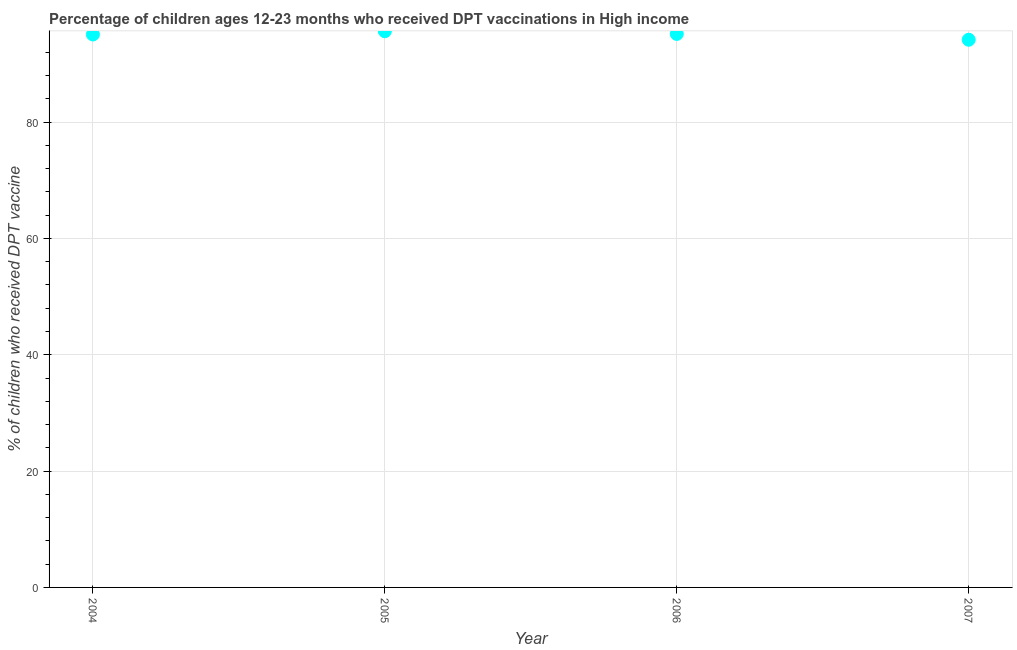What is the percentage of children who received dpt vaccine in 2006?
Your answer should be compact. 95.16. Across all years, what is the maximum percentage of children who received dpt vaccine?
Your response must be concise. 95.61. Across all years, what is the minimum percentage of children who received dpt vaccine?
Your answer should be very brief. 94.16. In which year was the percentage of children who received dpt vaccine minimum?
Your answer should be compact. 2007. What is the sum of the percentage of children who received dpt vaccine?
Ensure brevity in your answer.  379.98. What is the difference between the percentage of children who received dpt vaccine in 2004 and 2006?
Your answer should be compact. -0.1. What is the average percentage of children who received dpt vaccine per year?
Keep it short and to the point. 95. What is the median percentage of children who received dpt vaccine?
Provide a short and direct response. 95.11. In how many years, is the percentage of children who received dpt vaccine greater than 80 %?
Your response must be concise. 4. Do a majority of the years between 2006 and 2007 (inclusive) have percentage of children who received dpt vaccine greater than 28 %?
Ensure brevity in your answer.  Yes. What is the ratio of the percentage of children who received dpt vaccine in 2004 to that in 2005?
Your answer should be compact. 0.99. What is the difference between the highest and the second highest percentage of children who received dpt vaccine?
Your answer should be compact. 0.46. Is the sum of the percentage of children who received dpt vaccine in 2004 and 2007 greater than the maximum percentage of children who received dpt vaccine across all years?
Your answer should be compact. Yes. What is the difference between the highest and the lowest percentage of children who received dpt vaccine?
Offer a terse response. 1.46. What is the difference between two consecutive major ticks on the Y-axis?
Give a very brief answer. 20. Does the graph contain any zero values?
Provide a short and direct response. No. What is the title of the graph?
Offer a very short reply. Percentage of children ages 12-23 months who received DPT vaccinations in High income. What is the label or title of the Y-axis?
Ensure brevity in your answer.  % of children who received DPT vaccine. What is the % of children who received DPT vaccine in 2004?
Your answer should be compact. 95.06. What is the % of children who received DPT vaccine in 2005?
Give a very brief answer. 95.61. What is the % of children who received DPT vaccine in 2006?
Provide a succinct answer. 95.16. What is the % of children who received DPT vaccine in 2007?
Offer a very short reply. 94.16. What is the difference between the % of children who received DPT vaccine in 2004 and 2005?
Make the answer very short. -0.56. What is the difference between the % of children who received DPT vaccine in 2004 and 2006?
Make the answer very short. -0.1. What is the difference between the % of children who received DPT vaccine in 2004 and 2007?
Give a very brief answer. 0.9. What is the difference between the % of children who received DPT vaccine in 2005 and 2006?
Offer a very short reply. 0.46. What is the difference between the % of children who received DPT vaccine in 2005 and 2007?
Keep it short and to the point. 1.46. What is the difference between the % of children who received DPT vaccine in 2006 and 2007?
Make the answer very short. 1. What is the ratio of the % of children who received DPT vaccine in 2004 to that in 2005?
Offer a very short reply. 0.99. What is the ratio of the % of children who received DPT vaccine in 2005 to that in 2006?
Give a very brief answer. 1. What is the ratio of the % of children who received DPT vaccine in 2005 to that in 2007?
Ensure brevity in your answer.  1.01. 